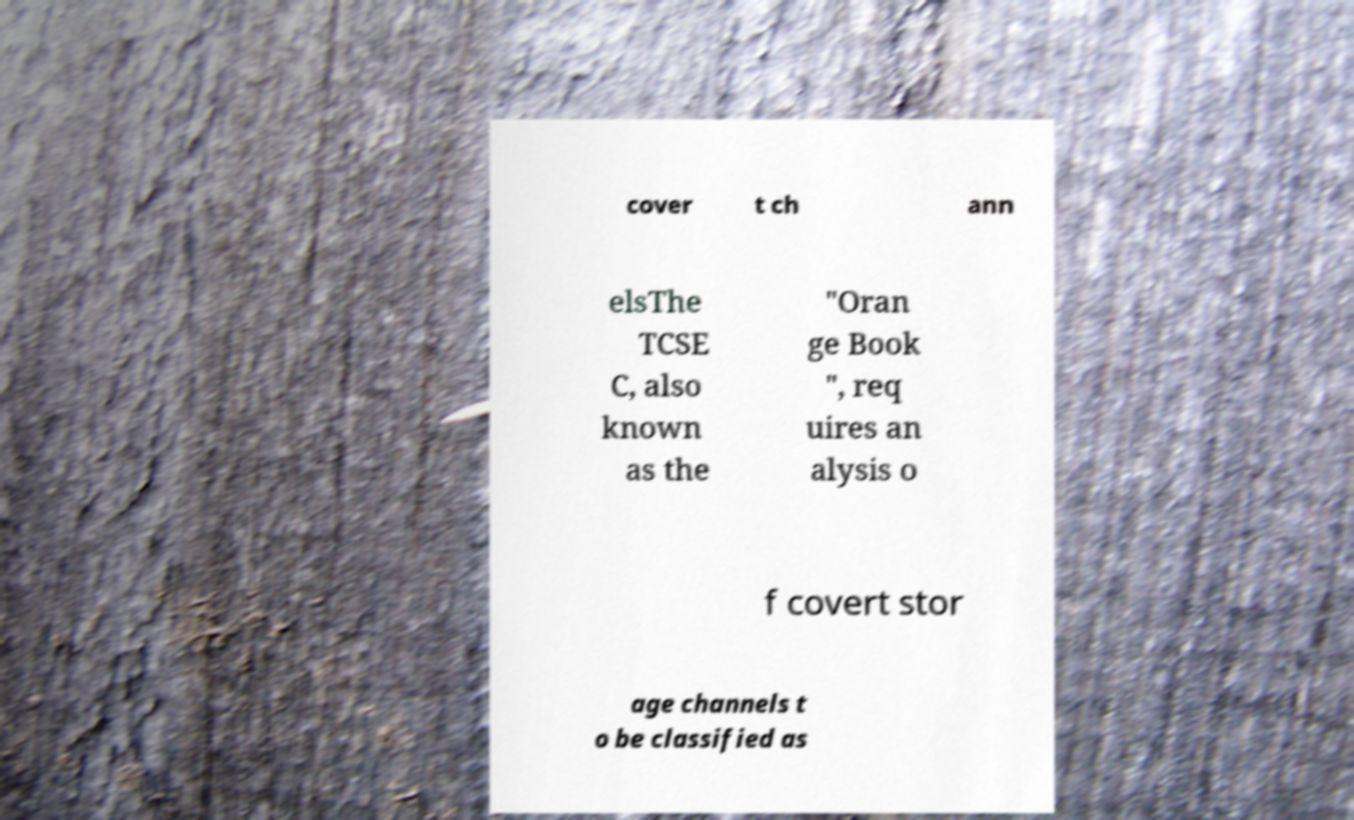Please identify and transcribe the text found in this image. cover t ch ann elsThe TCSE C, also known as the "Oran ge Book ", req uires an alysis o f covert stor age channels t o be classified as 